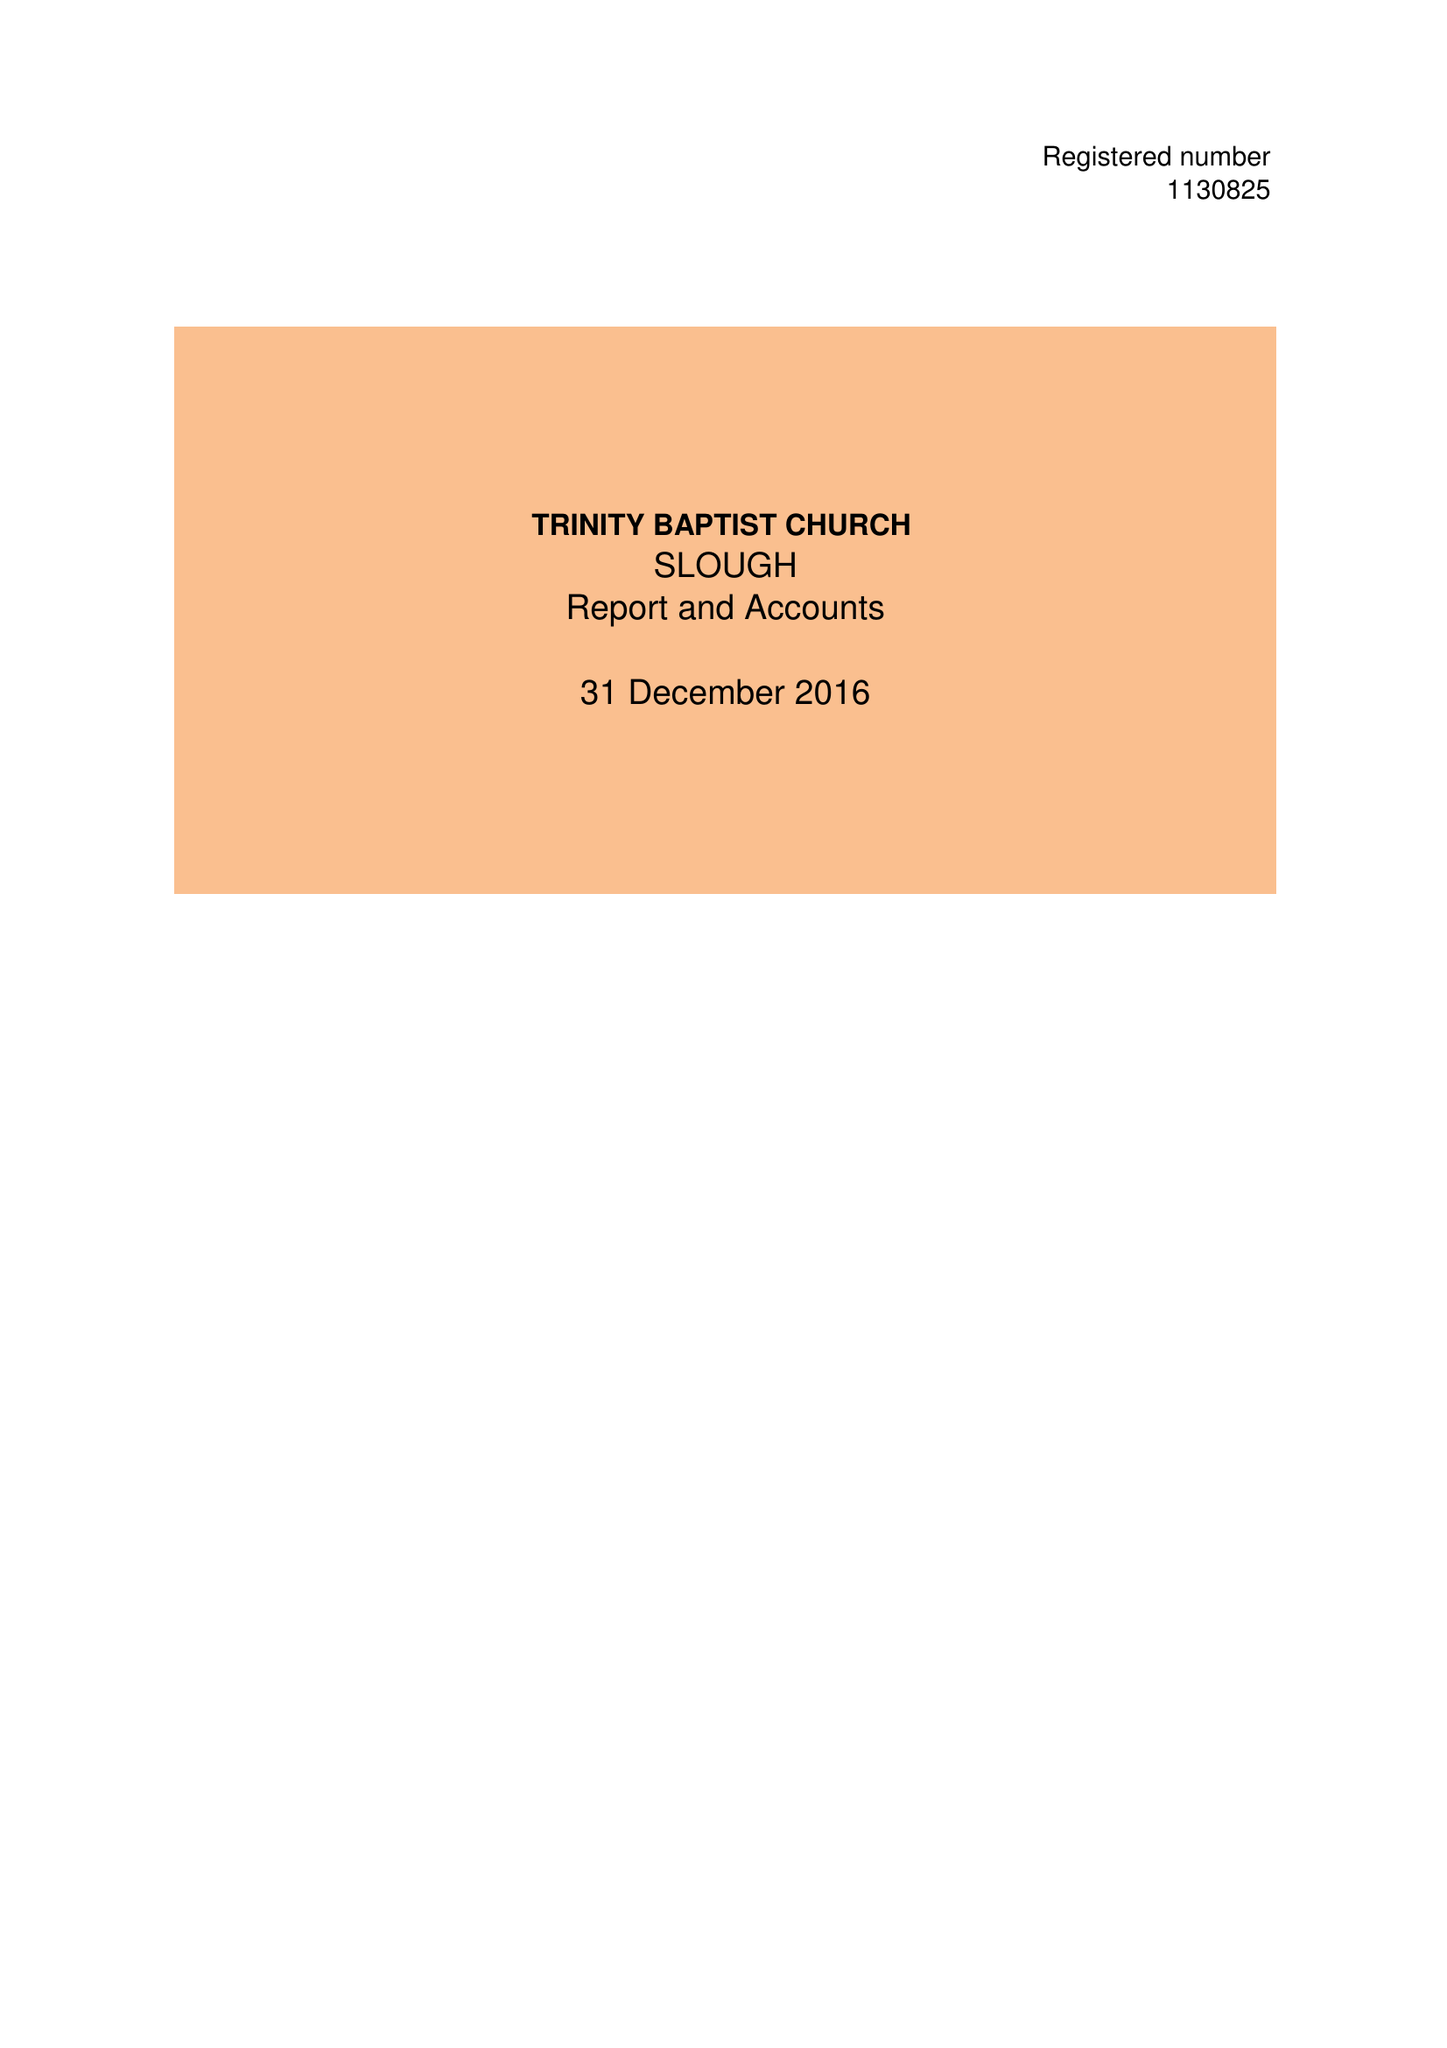What is the value for the charity_name?
Answer the question using a single word or phrase. Trinity Baptist Church Slough 